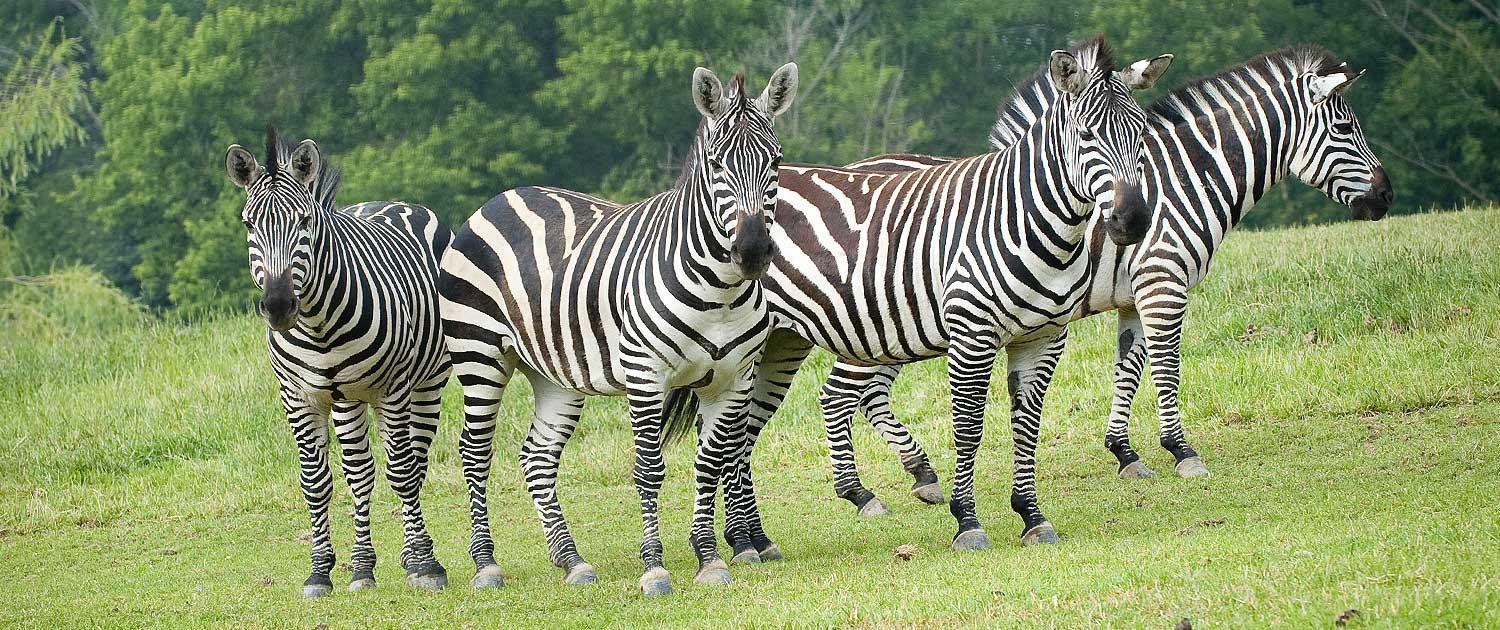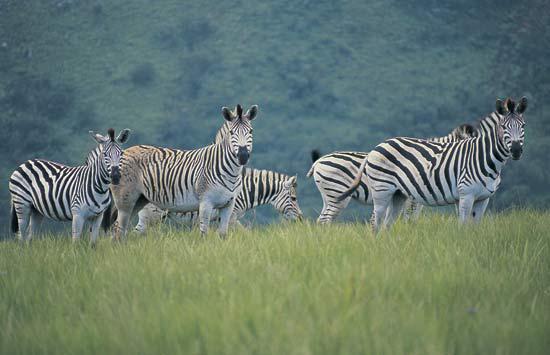The first image is the image on the left, the second image is the image on the right. Analyze the images presented: Is the assertion "One image shows leftward-facing zebras lined up with bent heads drinking from water they are standing in." valid? Answer yes or no. No. The first image is the image on the left, the second image is the image on the right. Analyze the images presented: Is the assertion "there are zebras standing in a row drinking water" valid? Answer yes or no. No. 